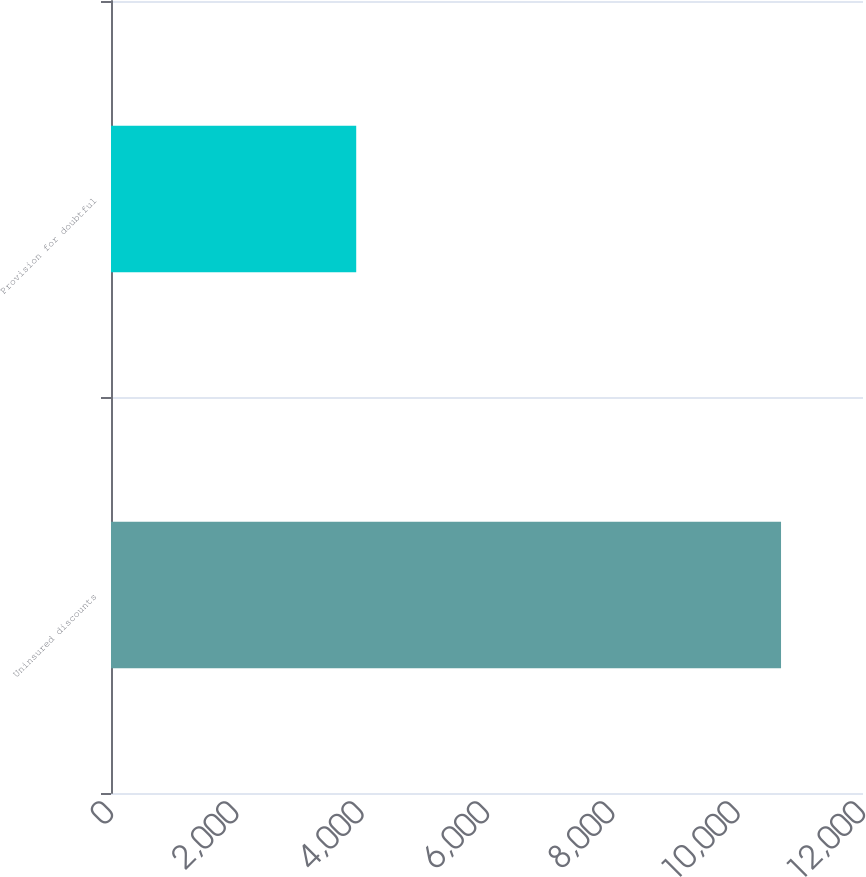<chart> <loc_0><loc_0><loc_500><loc_500><bar_chart><fcel>Uninsured discounts<fcel>Provision for doubtful<nl><fcel>10692<fcel>3913<nl></chart> 